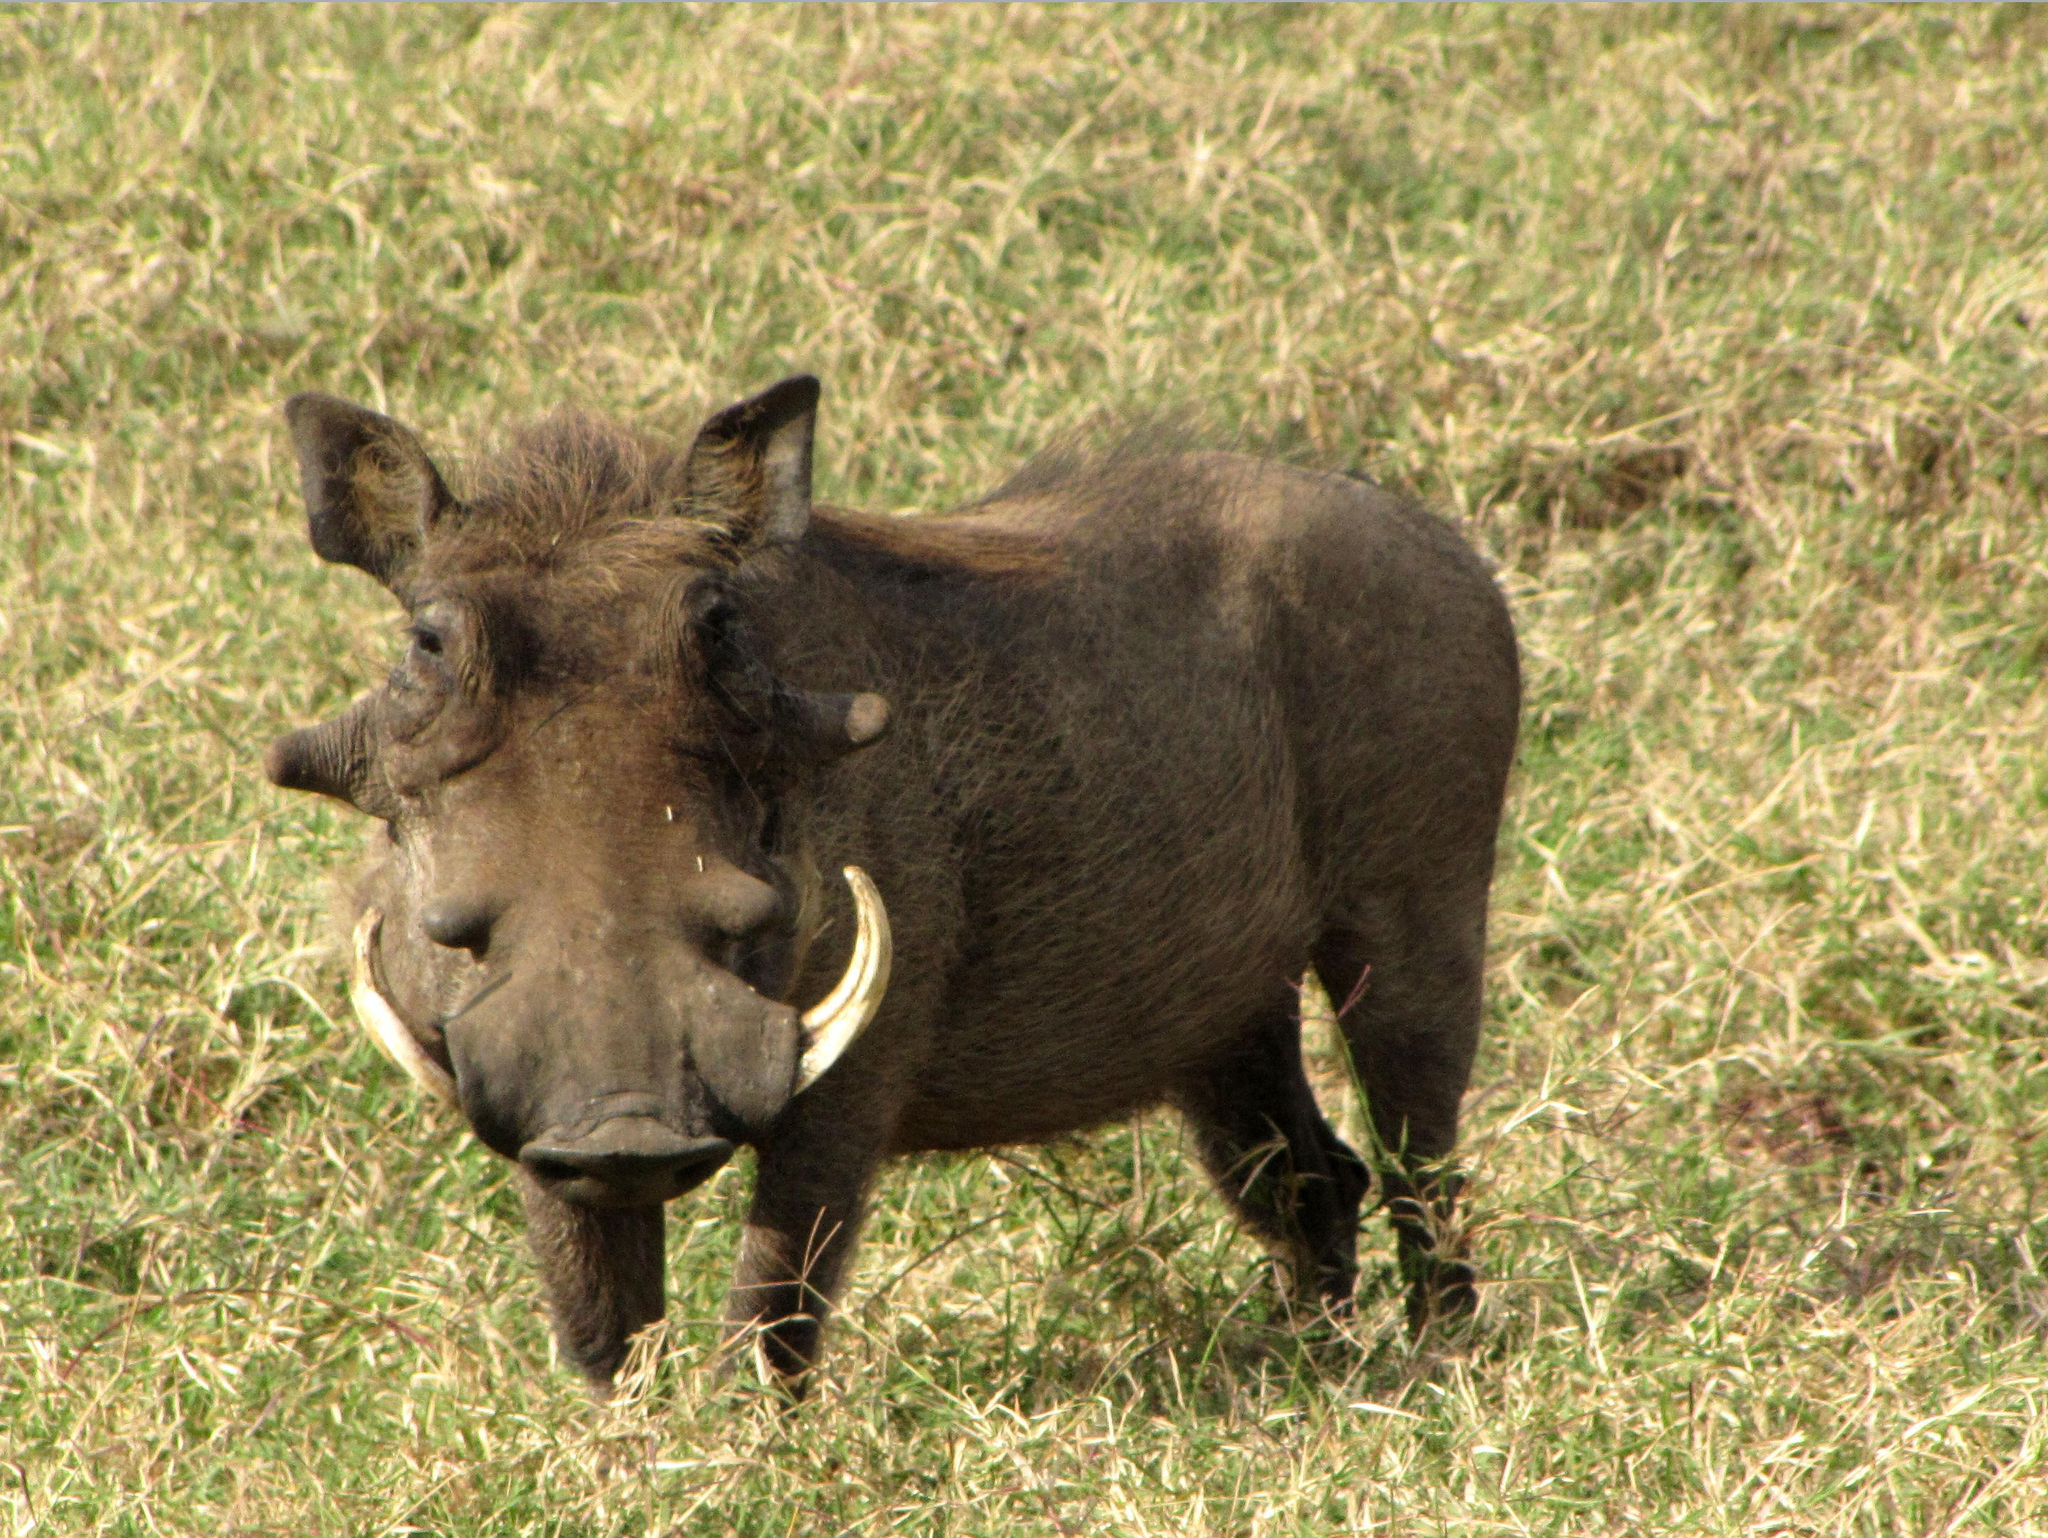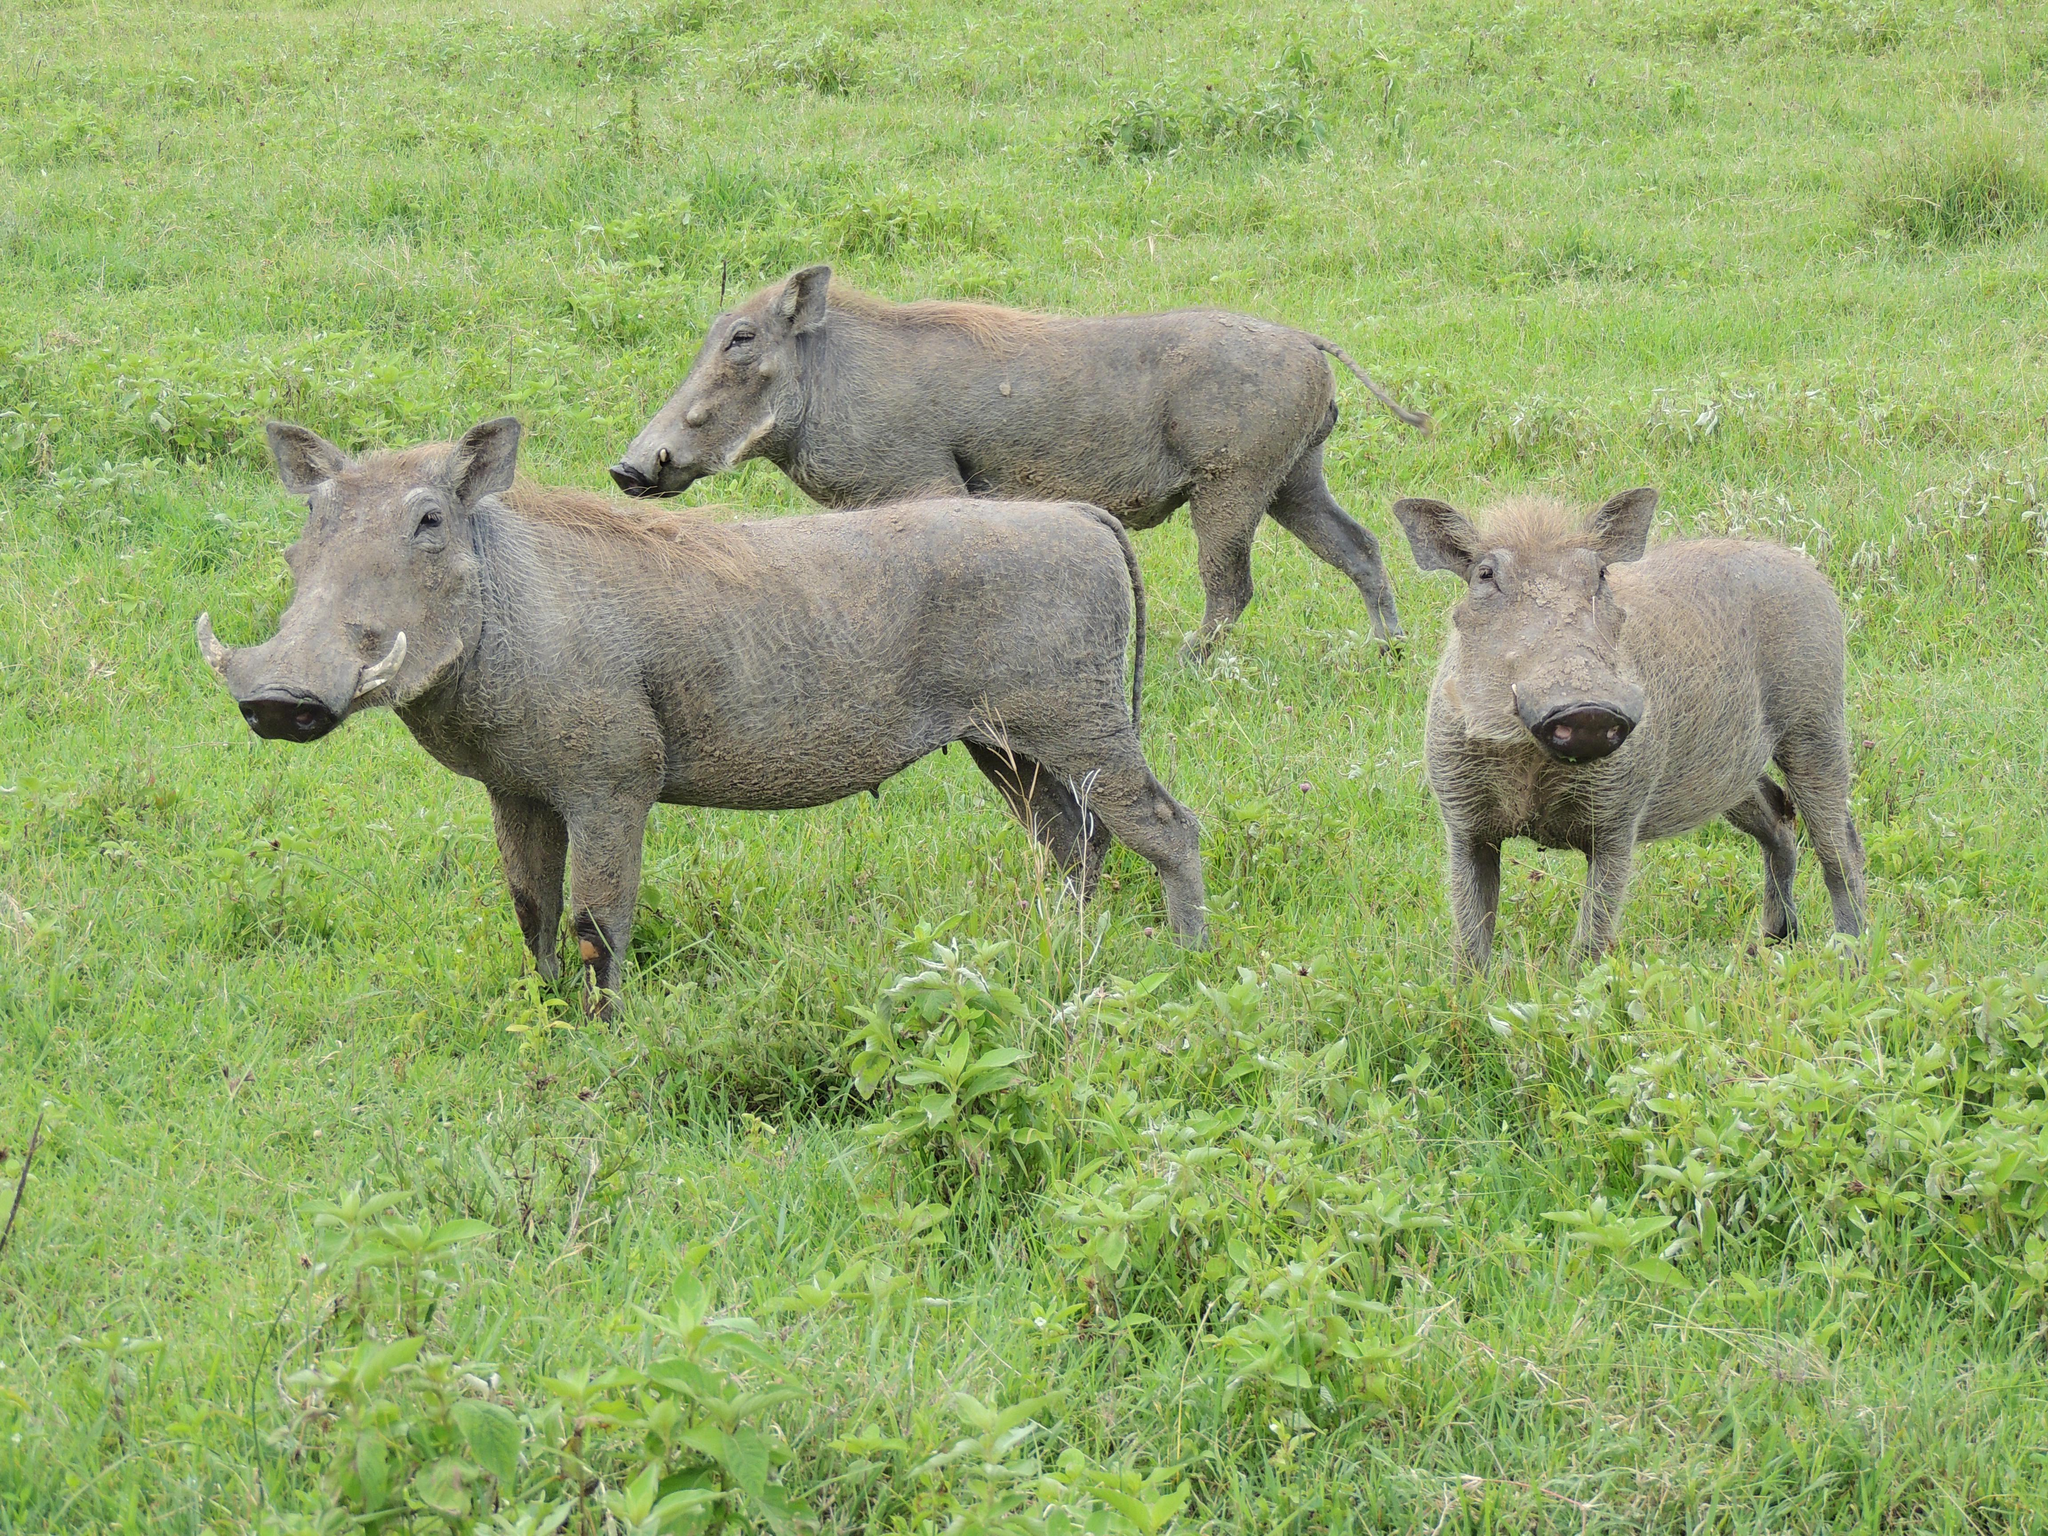The first image is the image on the left, the second image is the image on the right. Considering the images on both sides, is "A mother hog leads a farrow of at least two facing the background." valid? Answer yes or no. No. The first image is the image on the left, the second image is the image on the right. Examine the images to the left and right. Is the description "At least one image shows animals running away from the camera." accurate? Answer yes or no. No. 